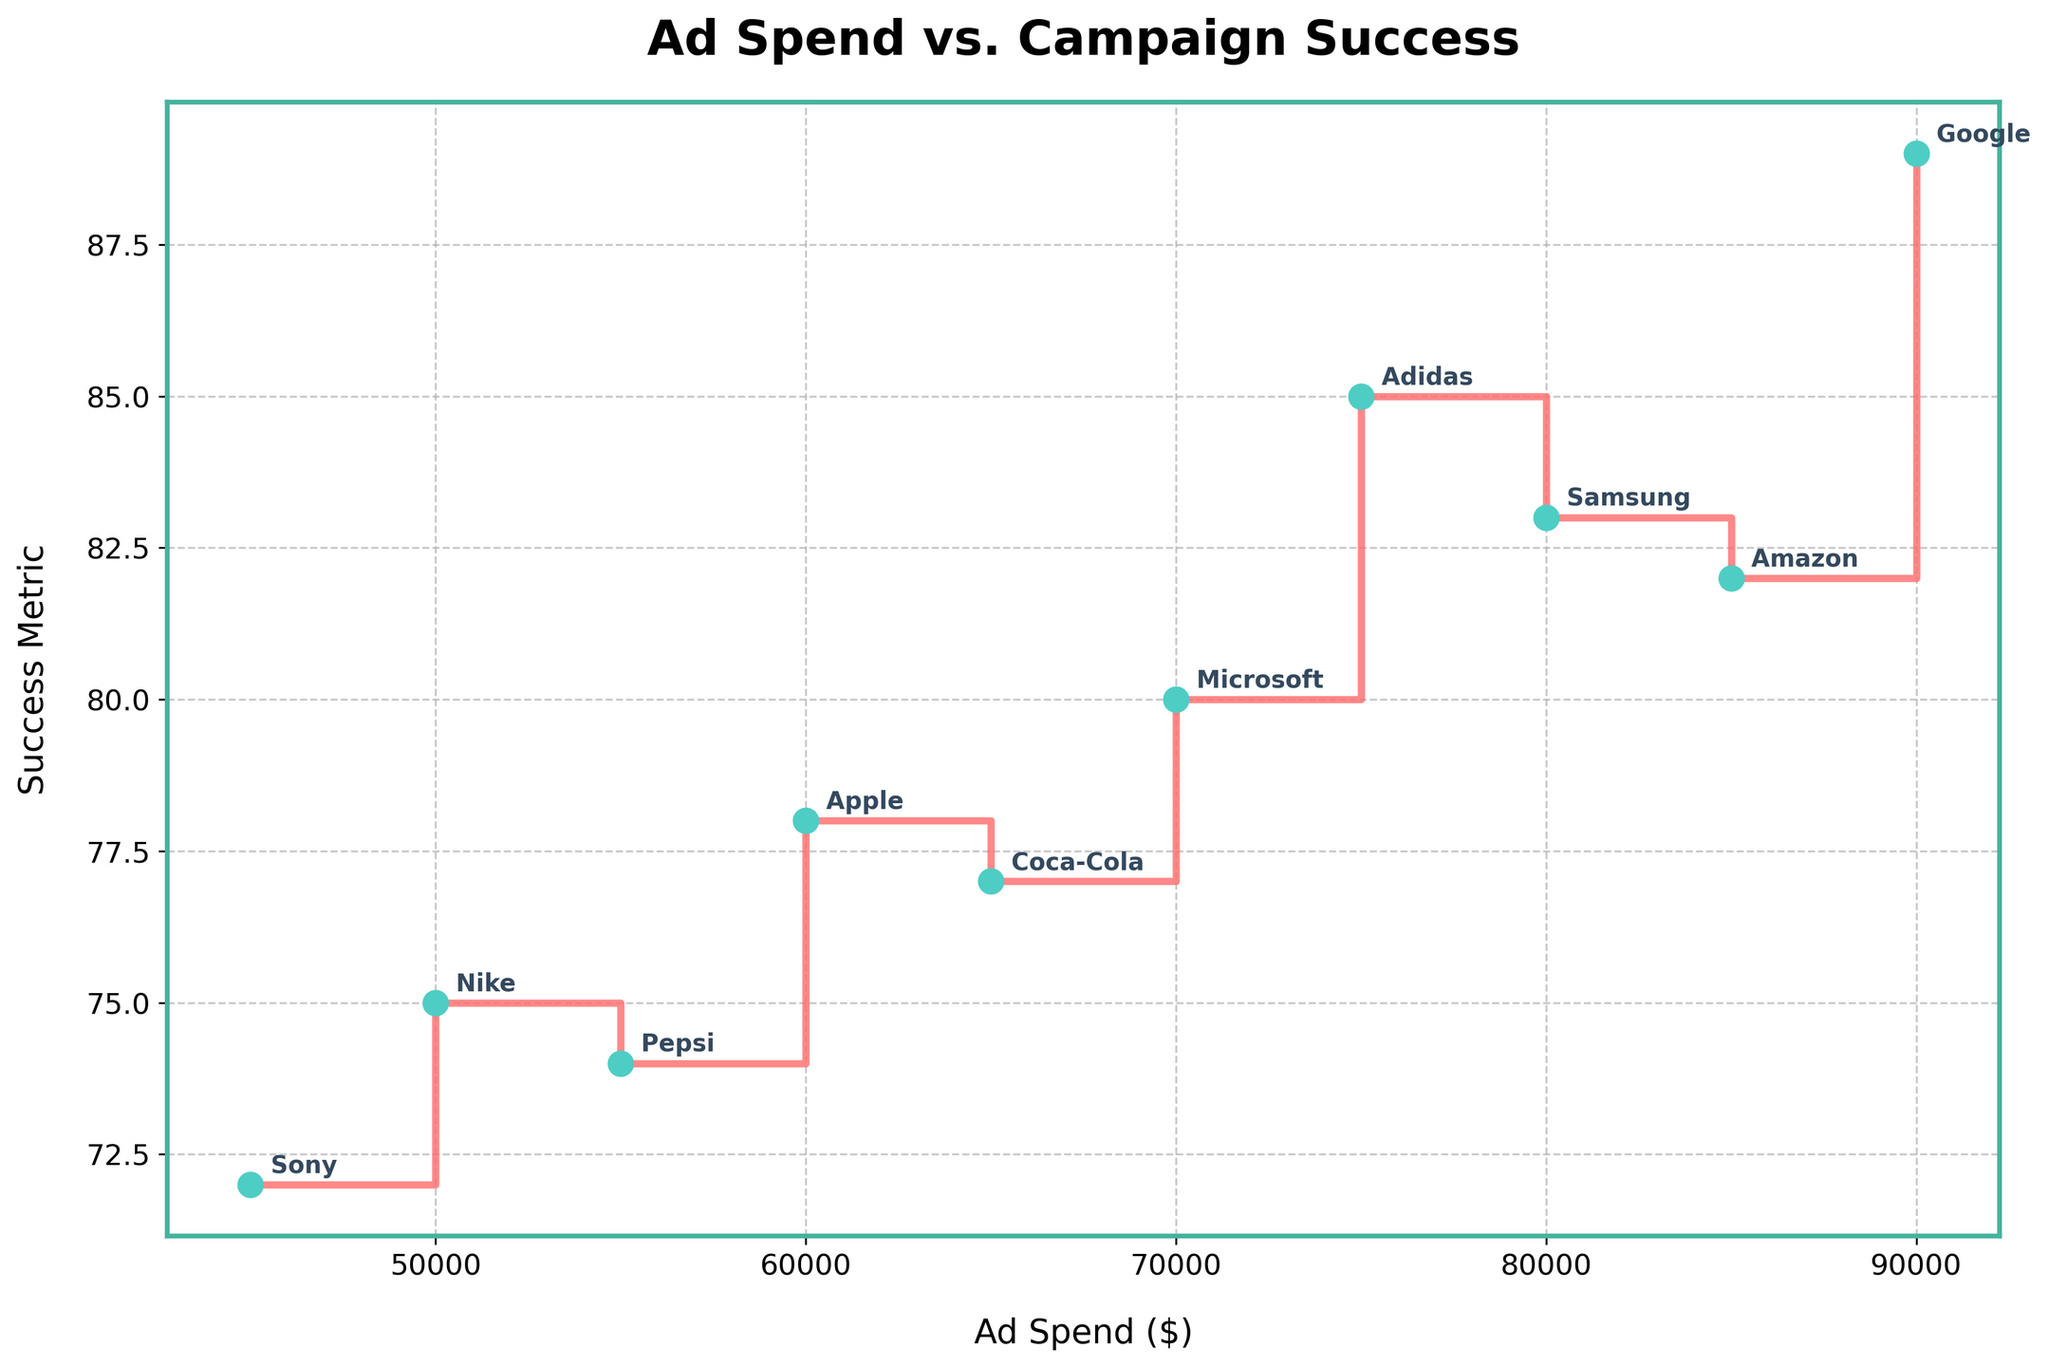What is the title of the figure? The title of the figure is displayed at the top and reads 'Ad Spend vs. Campaign Success'.
Answer: Ad Spend vs. Campaign Success What are the labels of the x-axis and y-axis? The x-axis is labeled 'Ad Spend ($)' and the y-axis is labeled 'Success Metric'.
Answer: Ad Spend ($) and Success Metric Which campaign had the highest ad spend? The campaign with the highest ad spend is evident by the data point farthest to the right on the x-axis, which corresponds to Google's campaign.
Answer: Google What is the success metric for the campaign with the lowest ad spend? Identify the leftmost point on the x-axis for the lowest ad spend, which is Sony's campaign with an ad spend of $45,000. The success metric at this point shows a value of 72.
Answer: 72 How many data points are there in the figure? Each campaign contributes one data point, with a total number of campaigns being 10.
Answer: 10 Which brand had the highest success metric and what was their ad spend? Observe the highest point on the y-axis for the success metric. Google is the brand with the highest success metric of 89, corresponding to an ad spend of $90,000.
Answer: Google with $90,000 ad spend Compare the success metrics of the campaigns with an ad spend of $70,000 and $75,000. Which one was more successful? Microsoft spent $70,000 with a success metric of 80, and Adidas spent $75,000 with a success metric of 85. Comparing these, Adidas was more successful.
Answer: Adidas with a success metric of 85 What is the median ad spend across all campaigns shown in the figure? To find the median ad spend, order the ad spends ($45,000, $50,000, $55,000, $60,000, $65,000, $70,000, $75,000, $80,000, $85,000, $90,000). Then, identify the middle value(s). Since there are 10 values, the median ad spend is the average of the 5th and 6th values: ($65,000 + $70,000)/2 = $67,500.
Answer: $67,500 What is the general trend shown in the plot? The general trend can be identified by observing the overall direction of the stair-steps in the plot. It generally shows that the success metric tends to increase as ad spend increases.
Answer: Success metric increases with higher ad spend Which two campaigns have nearly identical success metrics despite significant differences in ad spend, and what does this imply? Examine the y-values and note that Sony ($45,000, 72) and Pepsi ($55,000, 74) have very close success metrics despite the difference in their ad spends. This implies that higher ad spend does not always lead to significantly higher success.
Answer: Sony ($45,000) and Pepsi ($55,000) 